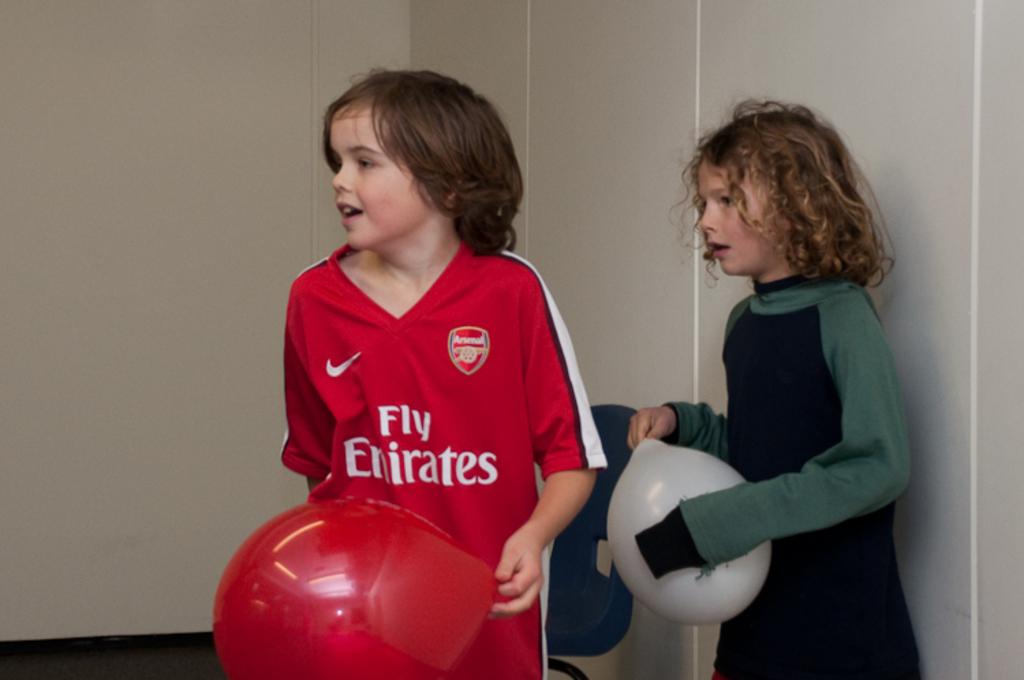What are the words on the red shirt?
Offer a terse response. Fly emirates. 